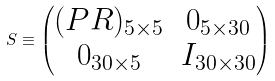<formula> <loc_0><loc_0><loc_500><loc_500>S \equiv \begin{pmatrix} ( P R ) _ { 5 \times 5 } & 0 _ { 5 \times 3 0 } \\ 0 _ { 3 0 \times 5 } & I _ { 3 0 \times 3 0 } \end{pmatrix}</formula> 